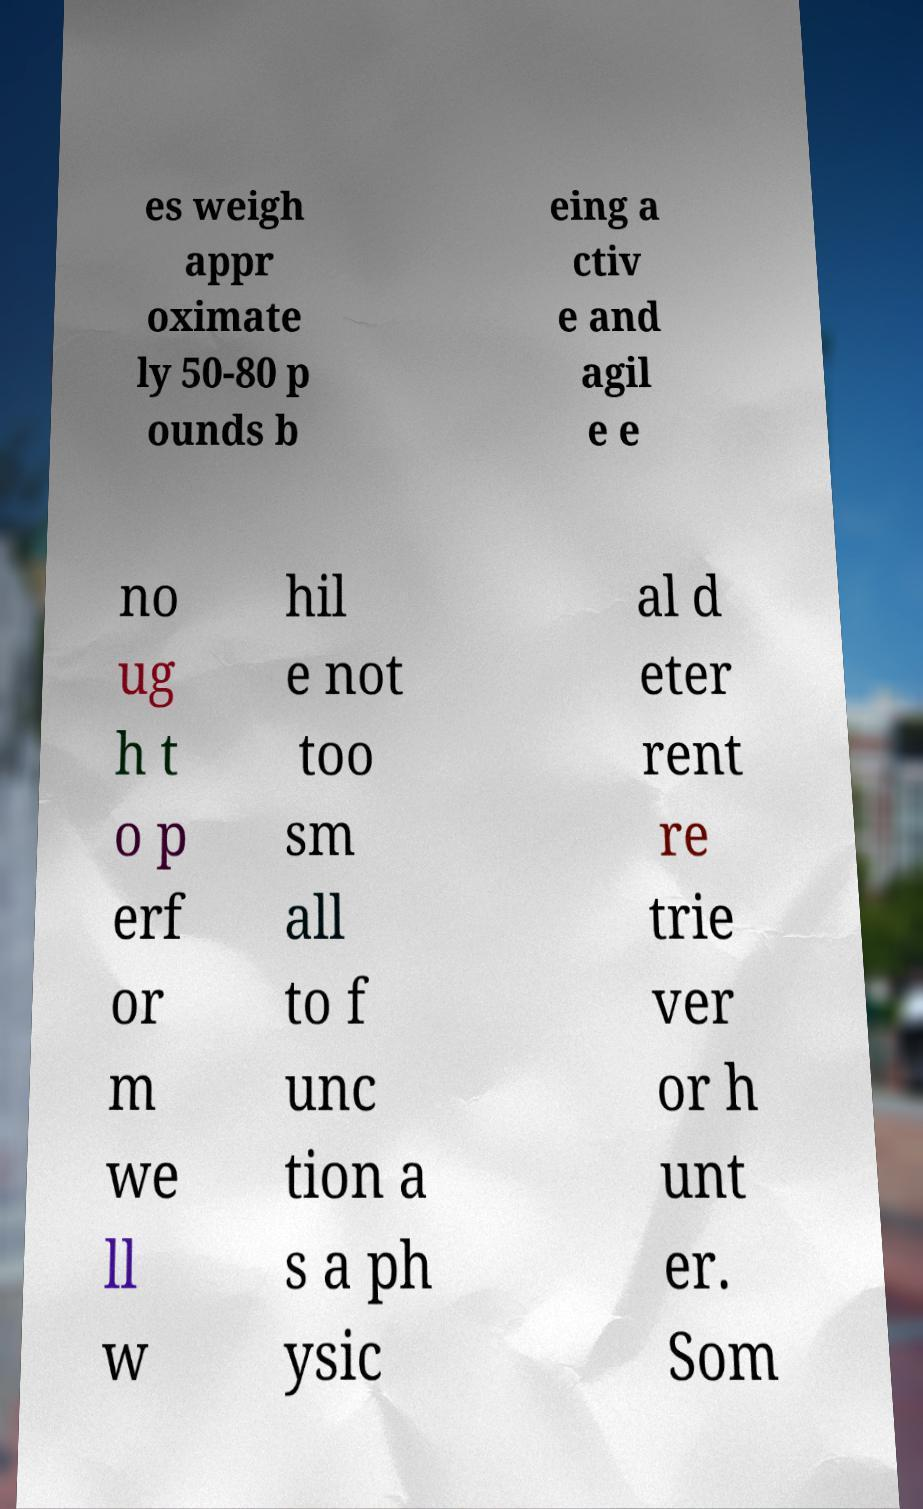What messages or text are displayed in this image? I need them in a readable, typed format. es weigh appr oximate ly 50-80 p ounds b eing a ctiv e and agil e e no ug h t o p erf or m we ll w hil e not too sm all to f unc tion a s a ph ysic al d eter rent re trie ver or h unt er. Som 